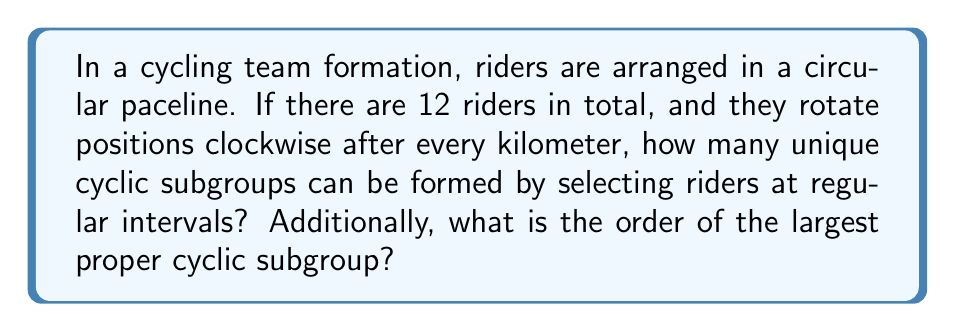Help me with this question. Let's approach this step-by-step:

1) First, we need to understand that this cycling formation can be represented as a cyclic group of order 12, which we can call $C_{12}$.

2) The number of unique cyclic subgroups is equal to the number of divisors of the group order. The divisors of 12 are 1, 2, 3, 4, 6, and 12.

3) For each divisor $d$, there is a unique subgroup of order $d$. Let's break this down:

   - For $d=1$: The identity subgroup (just one stationary rider)
   - For $d=2$: Subgroup of order 2 (every 6th rider)
   - For $d=3$: Subgroup of order 3 (every 4th rider)
   - For $d=4$: Subgroup of order 4 (every 3rd rider)
   - For $d=6$: Subgroup of order 6 (every 2nd rider)
   - For $d=12$: The entire group

4) Therefore, the number of unique cyclic subgroups is 6.

5) The largest proper cyclic subgroup would be the one with the largest order that is not the entire group. In this case, it's the subgroup of order 6.

6) We can represent this subgroup as:

   $$\langle r^2 \rangle = \{e, r^2, r^4, r^6, r^8, r^{10}\}$$

   Where $r$ represents a single rotation, and $e$ is the identity element.

This subgroup represents a formation where every other rider is selected, creating a group of 6 riders that rotates through all positions in the original 12-rider formation.
Answer: There are 6 unique cyclic subgroups. The largest proper cyclic subgroup has order 6. 